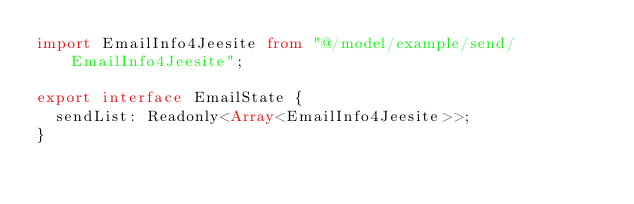Convert code to text. <code><loc_0><loc_0><loc_500><loc_500><_TypeScript_>import EmailInfo4Jeesite from "@/model/example/send/EmailInfo4Jeesite";

export interface EmailState {
  sendList: Readonly<Array<EmailInfo4Jeesite>>;
}
</code> 